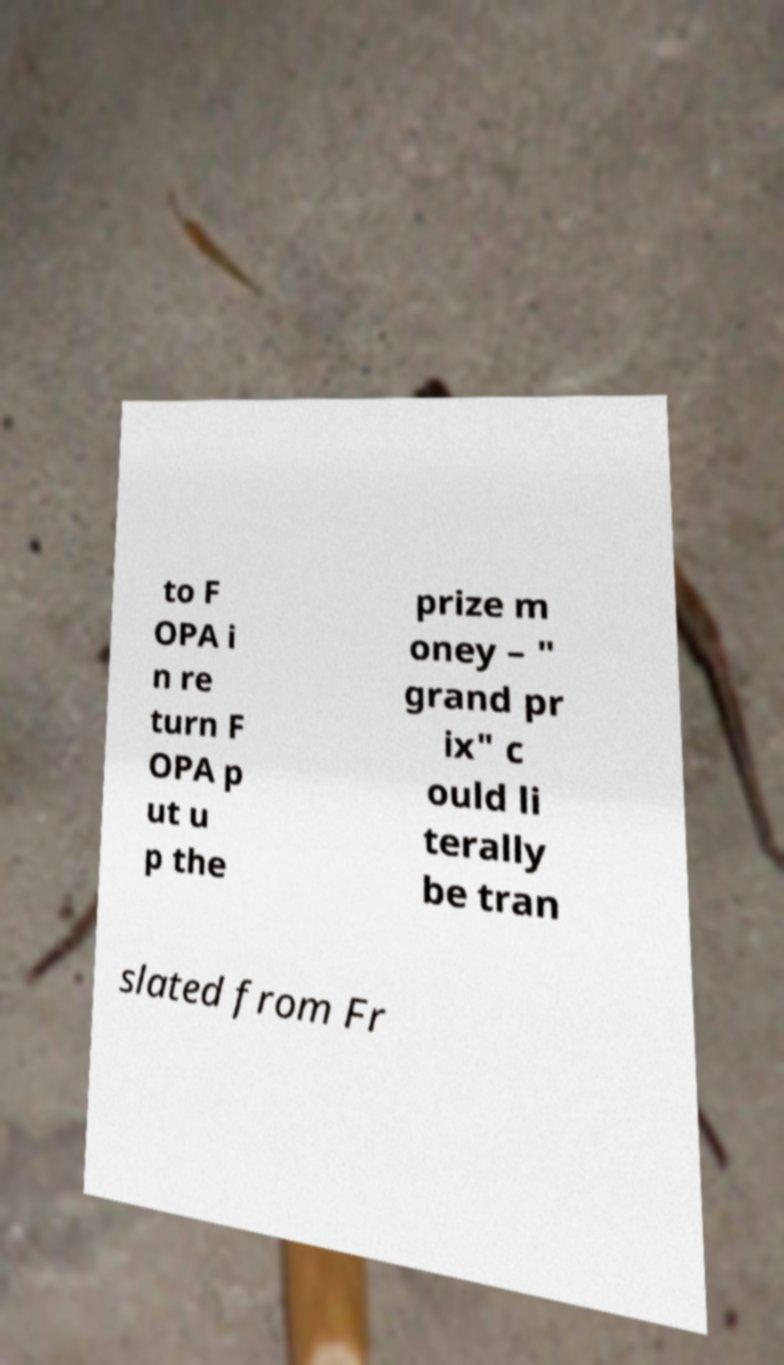There's text embedded in this image that I need extracted. Can you transcribe it verbatim? to F OPA i n re turn F OPA p ut u p the prize m oney – " grand pr ix" c ould li terally be tran slated from Fr 